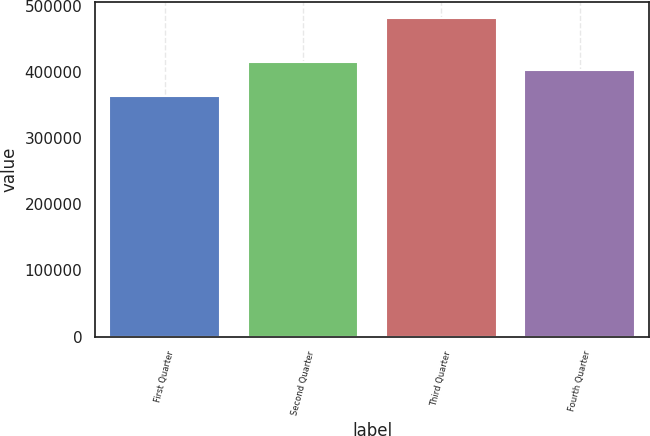Convert chart to OTSL. <chart><loc_0><loc_0><loc_500><loc_500><bar_chart><fcel>First Quarter<fcel>Second Quarter<fcel>Third Quarter<fcel>Fourth Quarter<nl><fcel>363461<fcel>414836<fcel>481103<fcel>403072<nl></chart> 